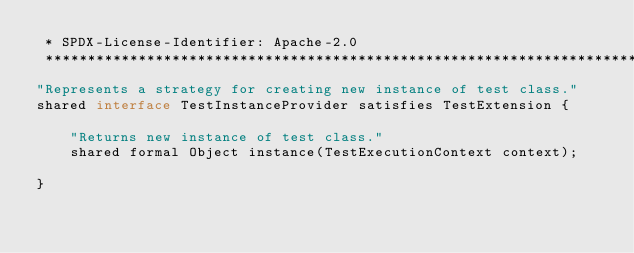Convert code to text. <code><loc_0><loc_0><loc_500><loc_500><_Ceylon_> * SPDX-License-Identifier: Apache-2.0 
 ********************************************************************************/
"Represents a strategy for creating new instance of test class."
shared interface TestInstanceProvider satisfies TestExtension {
    
    "Returns new instance of test class."
    shared formal Object instance(TestExecutionContext context);
    
}</code> 